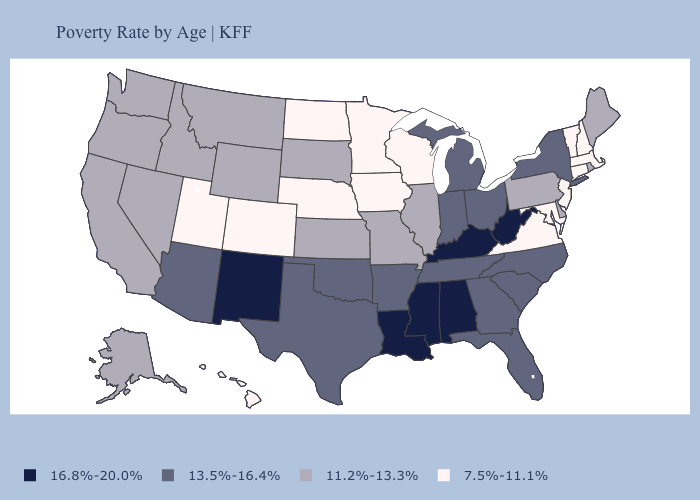What is the highest value in the West ?
Give a very brief answer. 16.8%-20.0%. Does Ohio have a lower value than Wisconsin?
Answer briefly. No. How many symbols are there in the legend?
Write a very short answer. 4. What is the value of North Dakota?
Short answer required. 7.5%-11.1%. Does Idaho have the highest value in the West?
Keep it brief. No. What is the value of Wyoming?
Answer briefly. 11.2%-13.3%. Name the states that have a value in the range 7.5%-11.1%?
Quick response, please. Colorado, Connecticut, Hawaii, Iowa, Maryland, Massachusetts, Minnesota, Nebraska, New Hampshire, New Jersey, North Dakota, Utah, Vermont, Virginia, Wisconsin. Name the states that have a value in the range 7.5%-11.1%?
Be succinct. Colorado, Connecticut, Hawaii, Iowa, Maryland, Massachusetts, Minnesota, Nebraska, New Hampshire, New Jersey, North Dakota, Utah, Vermont, Virginia, Wisconsin. Does New Hampshire have the lowest value in the Northeast?
Be succinct. Yes. Does New Mexico have the highest value in the West?
Write a very short answer. Yes. Does the map have missing data?
Keep it brief. No. Among the states that border Florida , does Alabama have the lowest value?
Be succinct. No. Name the states that have a value in the range 16.8%-20.0%?
Write a very short answer. Alabama, Kentucky, Louisiana, Mississippi, New Mexico, West Virginia. What is the lowest value in the USA?
Give a very brief answer. 7.5%-11.1%. 